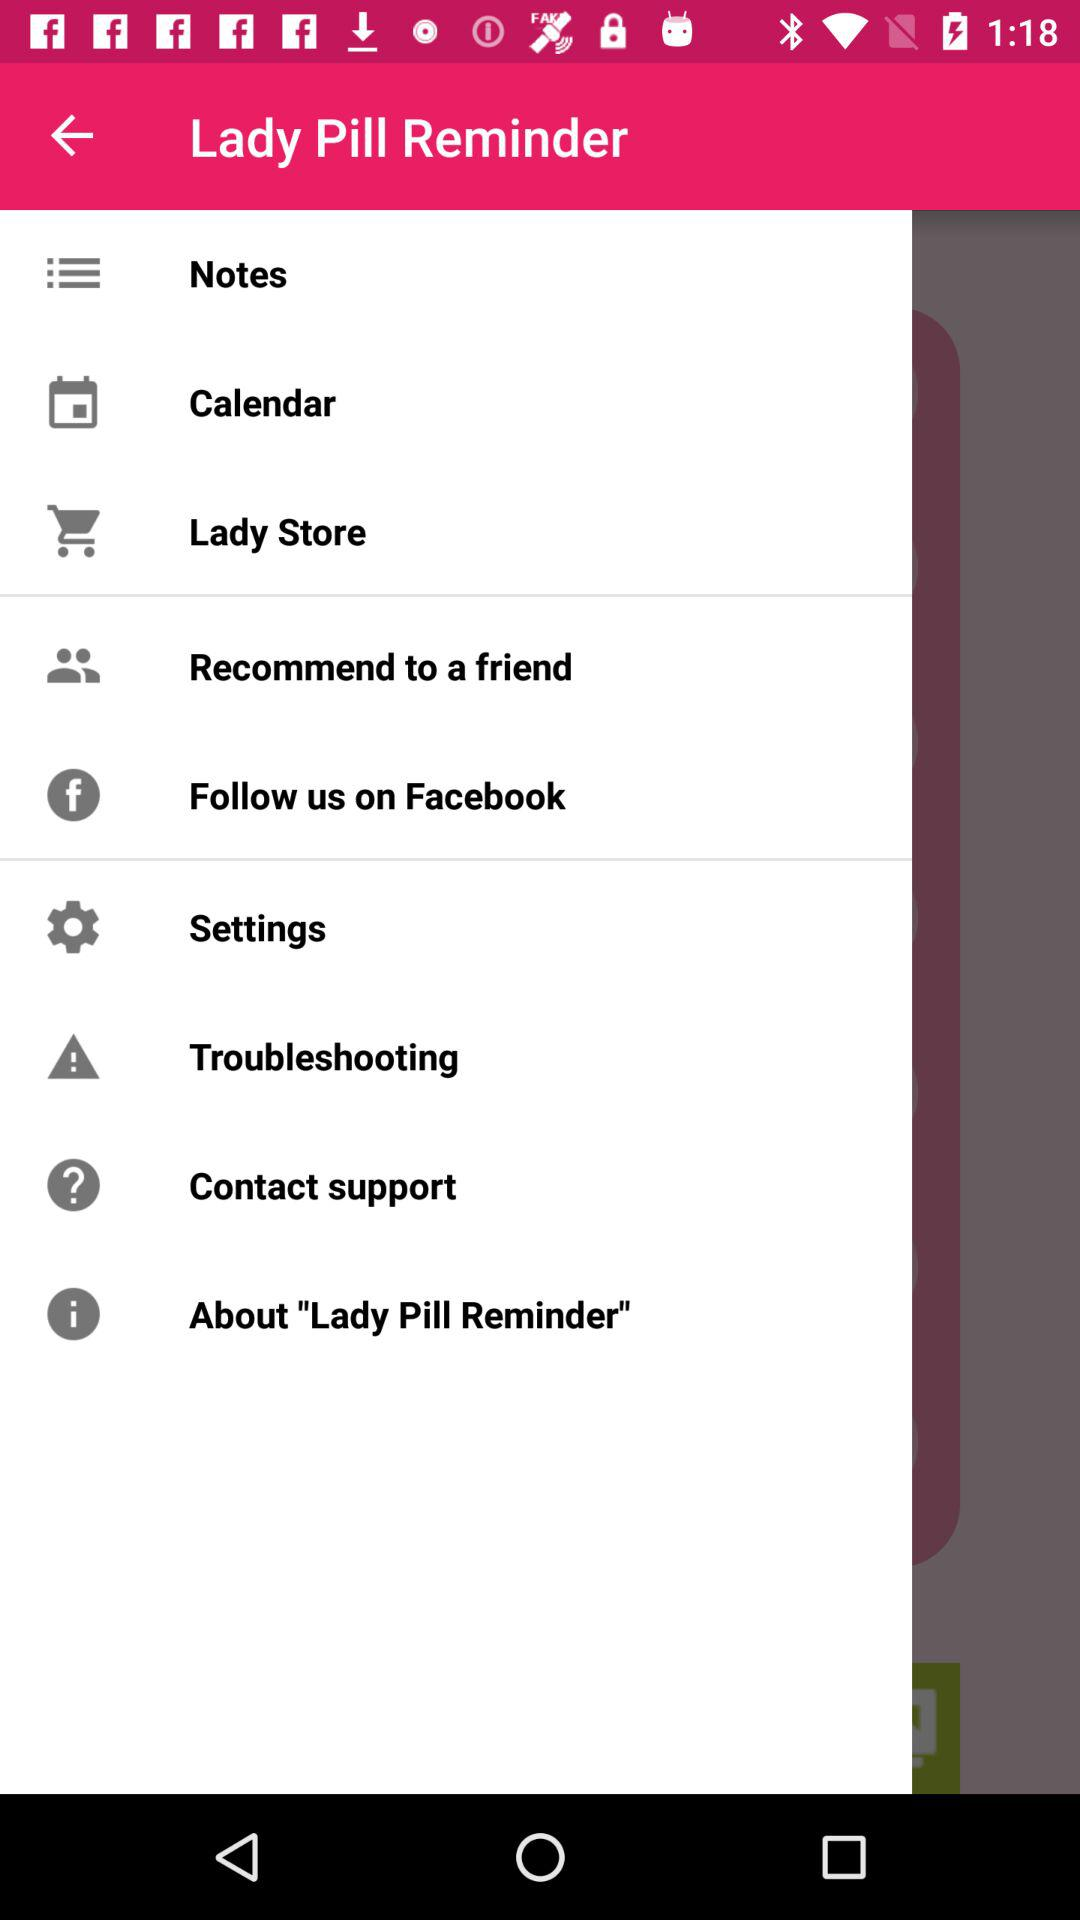What is the application name? The application name is "Lady Pill Reminder". 